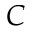Convert formula to latex. <formula><loc_0><loc_0><loc_500><loc_500>C</formula> 